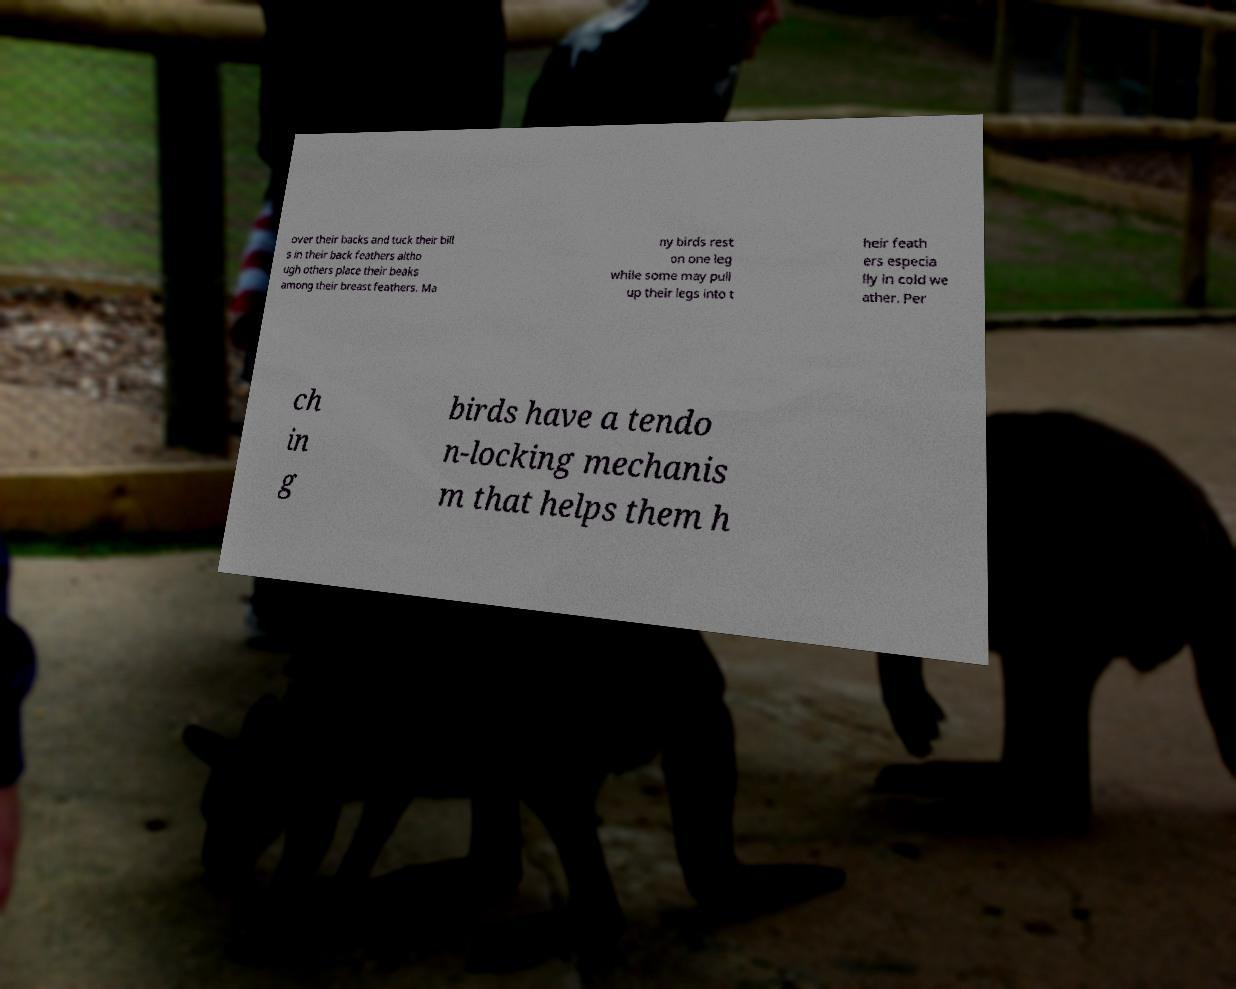What messages or text are displayed in this image? I need them in a readable, typed format. over their backs and tuck their bill s in their back feathers altho ugh others place their beaks among their breast feathers. Ma ny birds rest on one leg while some may pull up their legs into t heir feath ers especia lly in cold we ather. Per ch in g birds have a tendo n-locking mechanis m that helps them h 